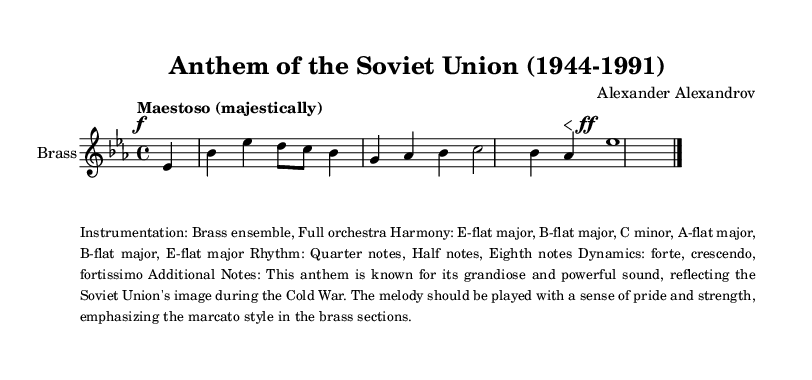What is the key signature of this music? The key signature has three flats, which indicates it is in E-flat major. To find the key signature, I looked at the number of flats listed at the beginning of the staff.
Answer: E-flat major What is the time signature of this music? The time signature appears at the beginning of the score as 4/4, meaning there are four beats in each measure, and the quarter note gets one beat. I identified this by examining the markings right after the key signature.
Answer: 4/4 What is the initial tempo marking given in this score? The tempo marking is noted as "Maestoso (majestically)" at the start of the score. This is indicated directly above the staff and specifies the overall character of the piece.
Answer: Maestoso What is the dynamic marking at the start of the music? The music starts with a dynamic marking of forte, indicated by the 'f' symbol placed right before the first note. This tells the performer to play loudly.
Answer: forte How many measures are indicated in the given section of music? The provided snippet consists of only one measure fully notated before it transitions to a placeholder for more measures. By counting the visual representation of the notes and rests, I confirm it is one complete measure.
Answer: 1 What is the instrumentation specified for this anthem? The sheet music specifies the instrumentation as "Brass ensemble, Full orchestra" in the additional notes section, which outlines the performing forces required. This is derived from the context provided in the markup section.
Answer: Brass ensemble, Full orchestra What type of musical phrases are indicated by the dynamics in this excerpt? The music features a dynamic change from forte to fortissimo, indicating a crescendo that builds powerful emotions. The instructions to play emphatically and with strength imply marcato style specifically for brass sections, reflecting strong emphasis on the melody.
Answer: forte to fortissimo 